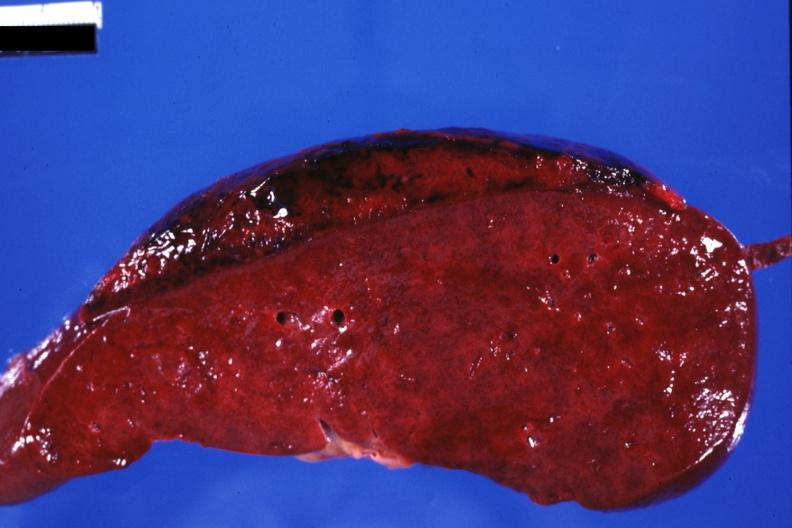does this image show sectioned spleen showing lesion very well?
Answer the question using a single word or phrase. Yes 